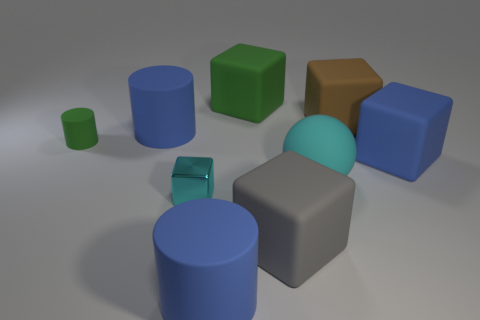Subtract all blue cubes. How many cubes are left? 4 Subtract all brown blocks. How many blocks are left? 4 Subtract all yellow cubes. Subtract all yellow cylinders. How many cubes are left? 5 Subtract all cylinders. How many objects are left? 6 Subtract 0 red cylinders. How many objects are left? 9 Subtract all purple cylinders. Subtract all matte cylinders. How many objects are left? 6 Add 8 small cyan metallic cubes. How many small cyan metallic cubes are left? 9 Add 9 big gray rubber cylinders. How many big gray rubber cylinders exist? 9 